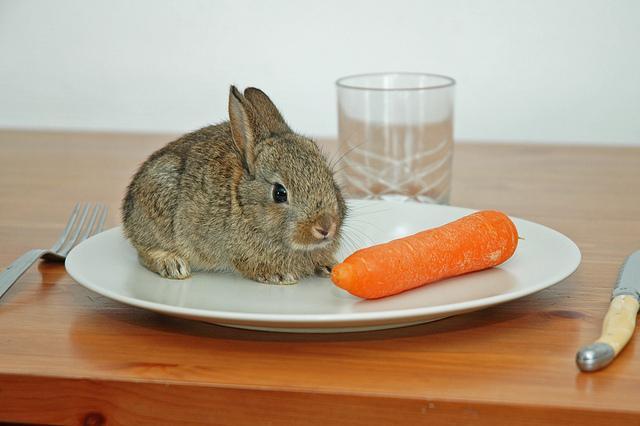How many forks are there?
Give a very brief answer. 1. 